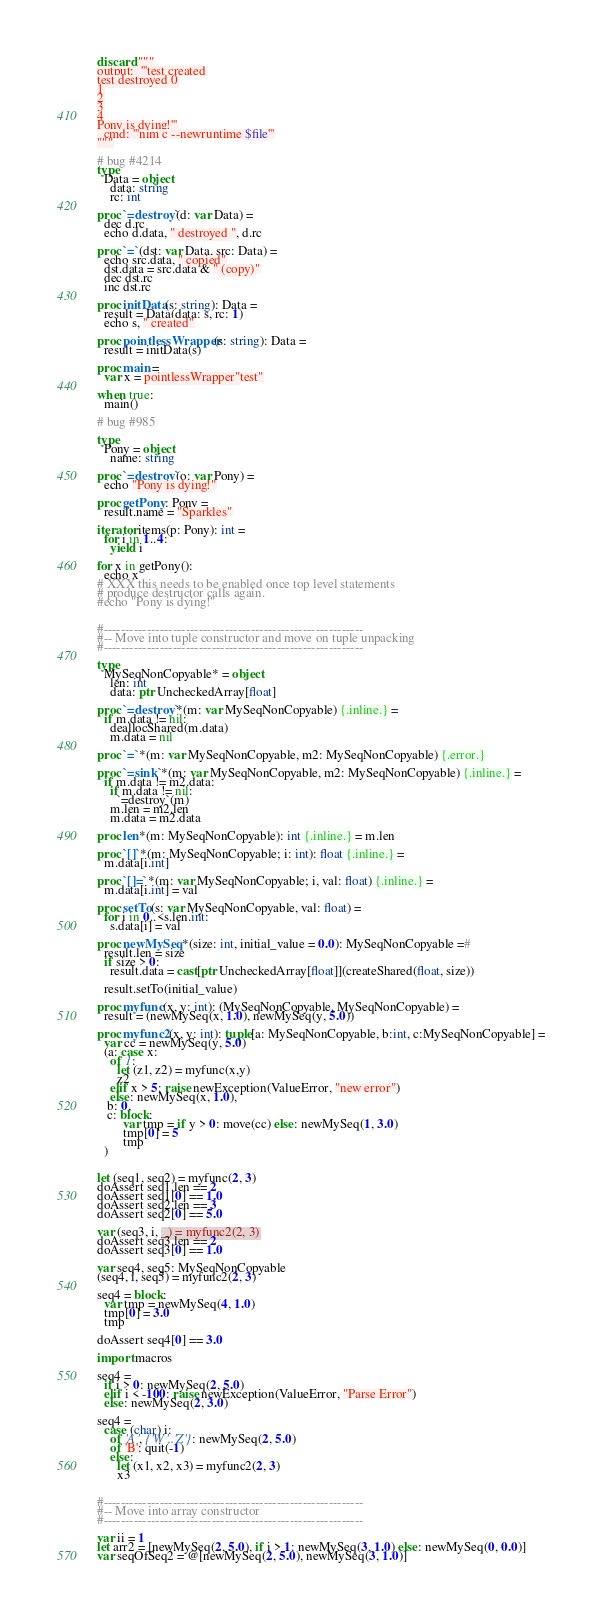<code> <loc_0><loc_0><loc_500><loc_500><_Nim_>
discard """
output:  '''test created
test destroyed 0
1
2
3
4
Pony is dying!'''
  cmd: '''nim c --newruntime $file'''
"""

# bug #4214
type
  Data = object
    data: string
    rc: int

proc `=destroy`(d: var Data) =
  dec d.rc
  echo d.data, " destroyed ", d.rc

proc `=`(dst: var Data, src: Data) =
  echo src.data, " copied"
  dst.data = src.data & " (copy)"
  dec dst.rc
  inc dst.rc

proc initData(s: string): Data =
  result = Data(data: s, rc: 1)
  echo s, " created"

proc pointlessWrapper(s: string): Data =
  result = initData(s)

proc main =
  var x = pointlessWrapper"test"

when true:
  main()

# bug #985

type
  Pony = object
    name: string

proc `=destroy`(o: var Pony) =
  echo "Pony is dying!"

proc getPony: Pony =
  result.name = "Sparkles"

iterator items(p: Pony): int =
  for i in 1..4:
    yield i

for x in getPony():
  echo x
# XXX this needs to be enabled once top level statements
# produce destructor calls again.
#echo "Pony is dying!"


#------------------------------------------------------------
#-- Move into tuple constructor and move on tuple unpacking
#------------------------------------------------------------

type
  MySeqNonCopyable* = object
    len: int 
    data: ptr UncheckedArray[float]

proc `=destroy`*(m: var MySeqNonCopyable) {.inline.} =
  if m.data != nil:
    deallocShared(m.data)
    m.data = nil

proc `=`*(m: var MySeqNonCopyable, m2: MySeqNonCopyable) {.error.}

proc `=sink`*(m: var MySeqNonCopyable, m2: MySeqNonCopyable) {.inline.} =
  if m.data != m2.data:
    if m.data != nil:
      `=destroy`(m)
    m.len = m2.len
    m.data = m2.data

proc len*(m: MySeqNonCopyable): int {.inline.} = m.len

proc `[]`*(m: MySeqNonCopyable; i: int): float {.inline.} =
  m.data[i.int]

proc `[]=`*(m: var MySeqNonCopyable; i, val: float) {.inline.} =
  m.data[i.int] = val

proc setTo(s: var MySeqNonCopyable, val: float) = 
  for i in 0..<s.len.int:
    s.data[i] = val

proc newMySeq*(size: int, initial_value = 0.0): MySeqNonCopyable =#
  result.len = size
  if size > 0:
    result.data = cast[ptr UncheckedArray[float]](createShared(float, size))

  result.setTo(initial_value)

proc myfunc(x, y: int): (MySeqNonCopyable, MySeqNonCopyable) =
  result = (newMySeq(x, 1.0), newMySeq(y, 5.0))

proc myfunc2(x, y: int): tuple[a: MySeqNonCopyable, b:int, c:MySeqNonCopyable] =
  var cc = newMySeq(y, 5.0)
  (a: case x:
    of 1: 
      let (z1, z2) = myfunc(x,y)
      z2
    elif x > 5: raise newException(ValueError, "new error")
    else: newMySeq(x, 1.0), 
   b: 0, 
   c: block:
        var tmp = if y > 0: move(cc) else: newMySeq(1, 3.0)
        tmp[0] = 5
        tmp 
  )
   

let (seq1, seq2) = myfunc(2, 3)
doAssert seq1.len == 2
doAssert seq1[0] == 1.0
doAssert seq2.len == 3
doAssert seq2[0] == 5.0

var (seq3, i, _) = myfunc2(2, 3)
doAssert seq3.len == 2
doAssert seq3[0] == 1.0

var seq4, seq5: MySeqNonCopyable
(seq4, i, seq5) = myfunc2(2, 3)

seq4 = block:
  var tmp = newMySeq(4, 1.0)
  tmp[0] = 3.0
  tmp

doAssert seq4[0] == 3.0 

import macros

seq4 = 
  if i > 0: newMySeq(2, 5.0) 
  elif i < -100: raise newException(ValueError, "Parse Error")
  else: newMySeq(2, 3.0)

seq4 = 
  case (char) i:
    of 'A', {'W'..'Z'}: newMySeq(2, 5.0) 
    of 'B': quit(-1)
    else: 
      let (x1, x2, x3) = myfunc2(2, 3)
      x3


#------------------------------------------------------------
#-- Move into array constructor
#------------------------------------------------------------

var ii = 1
let arr2 = [newMySeq(2, 5.0), if i > 1: newMySeq(3, 1.0) else: newMySeq(0, 0.0)]
var seqOfSeq2 = @[newMySeq(2, 5.0), newMySeq(3, 1.0)]
</code> 